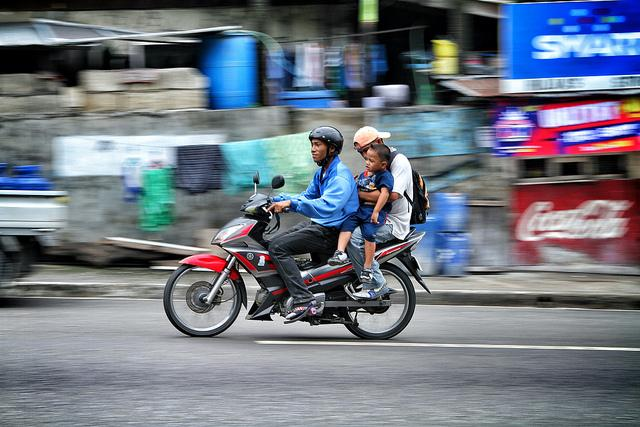What year was Coca-Cola founded? Please explain your reasoning. 1892. The coca cola company, featured here in the advertisement on the right side of the picture was founded 1892. 